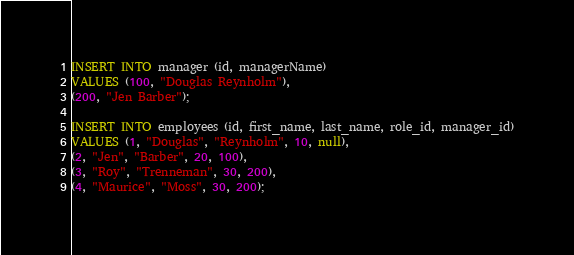Convert code to text. <code><loc_0><loc_0><loc_500><loc_500><_SQL_>
INSERT INTO manager (id, managerName)
VALUES (100, "Douglas Reynholm"),
(200, "Jen Barber");

INSERT INTO employees (id, first_name, last_name, role_id, manager_id)
VALUES (1, "Douglas", "Reynholm", 10, null),
(2, "Jen", "Barber", 20, 100),
(3, "Roy", "Trenneman", 30, 200),
(4, "Maurice", "Moss", 30, 200);


</code> 